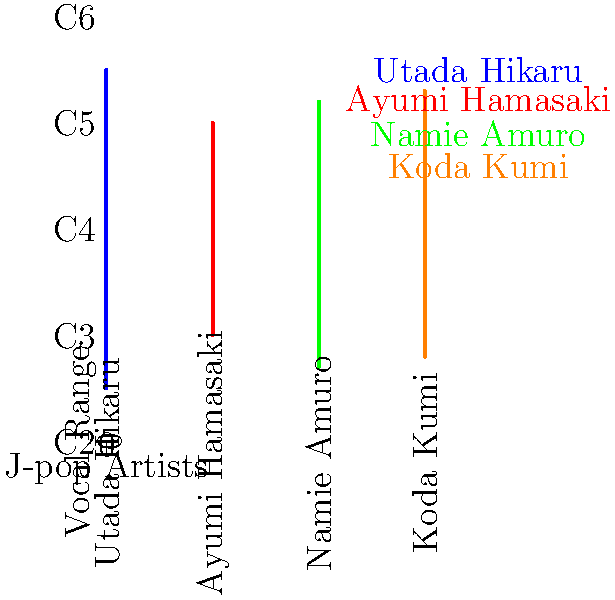Based on the vocal range chart, which J-pop artist has the widest vocal range, and approximately how many octaves does it span? To determine the artist with the widest vocal range and calculate the span in octaves:

1. Examine each artist's range on the chart:
   - Utada Hikaru: C3 to F5 (blue line)
   - Ayumi Hamasaki: G3 to C5 (red line)
   - Namie Amuro: E3 to E5 (green line)
   - Koda Kumi: F3 to F5 (orange line)

2. Identify the widest range:
   Utada Hikaru has the widest range, spanning from C3 to F5.

3. Calculate the span in octaves:
   - C3 to C4 is one octave
   - C4 to C5 is another octave
   - C5 to F5 is an additional perfect fourth

4. Convert to octaves:
   2 octaves + perfect fourth ≈ 2.33 octaves

Therefore, Utada Hikaru has the widest vocal range, spanning approximately 2.33 octaves.
Answer: Utada Hikaru, 2.33 octaves 